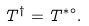Convert formula to latex. <formula><loc_0><loc_0><loc_500><loc_500>T ^ { \dag } = T ^ { * \circ } .</formula> 